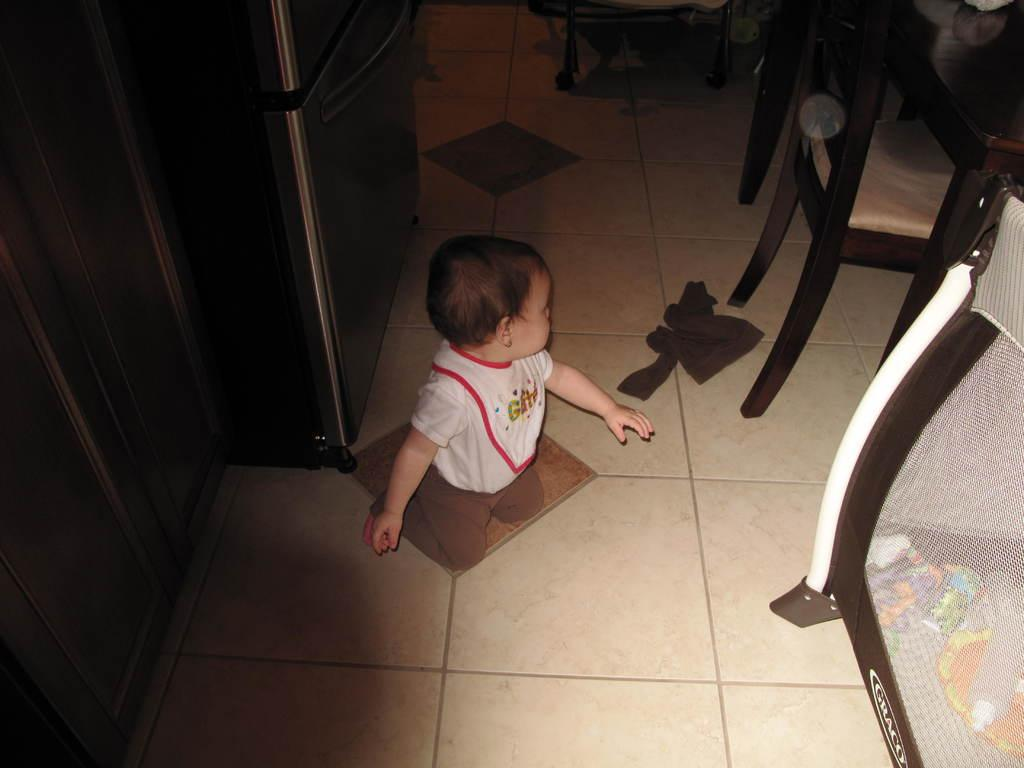What is the main subject of the image? The main subject of the image is a little cute guy sitting on the floor. What is the little cute guy wearing? The little cute guy is wearing a white color t-shirt. What can be seen on the right side of the image? There are chairs on the right side of the image. How many giraffes can be seen in the image? There are no giraffes present in the image. What time is displayed on the clocks in the image? There are no clocks present in the image. 